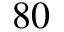<formula> <loc_0><loc_0><loc_500><loc_500>8 0</formula> 